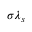Convert formula to latex. <formula><loc_0><loc_0><loc_500><loc_500>\sigma \lambda _ { s }</formula> 